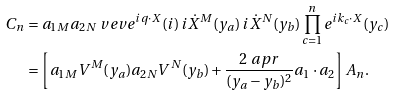<formula> <loc_0><loc_0><loc_500><loc_500>C _ { n } & = a _ { 1 M } a _ { 2 N } \ v e v { e ^ { i q \cdot X } ( i ) \, i \dot { X } ^ { M } ( y _ { a } ) \, i \dot { X } ^ { N } ( y _ { b } ) \prod _ { c = 1 } ^ { n } e ^ { i k _ { c } \cdot X } ( y _ { c } ) } \\ & = \left [ a _ { 1 M } V ^ { M } ( y _ { a } ) a _ { 2 N } V ^ { N } ( y _ { b } ) + \frac { 2 \ a p r } { ( y _ { a } - y _ { b } ) ^ { 2 } } a _ { 1 } \cdot a _ { 2 } \right ] A _ { n } .</formula> 